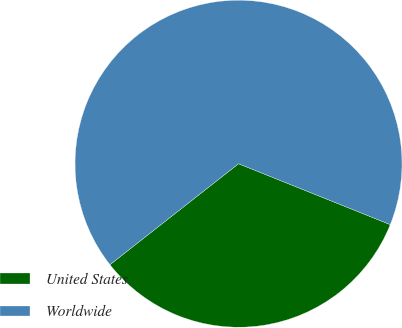Convert chart. <chart><loc_0><loc_0><loc_500><loc_500><pie_chart><fcel>United States<fcel>Worldwide<nl><fcel>33.33%<fcel>66.67%<nl></chart> 